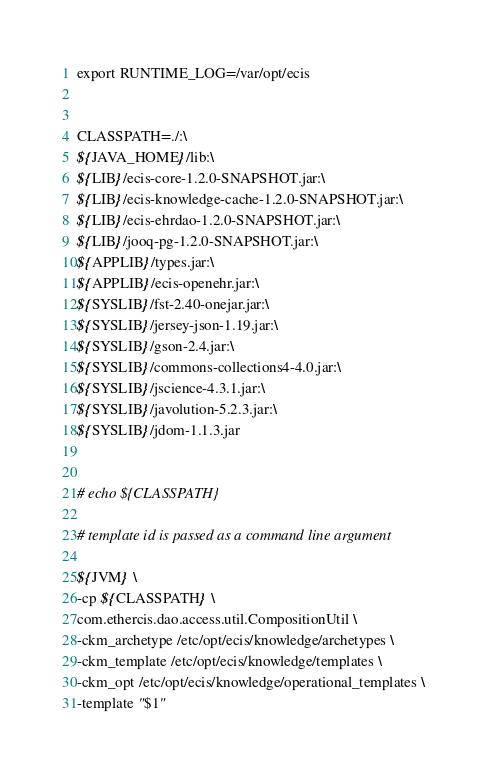Convert code to text. <code><loc_0><loc_0><loc_500><loc_500><_Bash_>export RUNTIME_LOG=/var/opt/ecis


CLASSPATH=./:\
${JAVA_HOME}/lib:\
${LIB}/ecis-core-1.2.0-SNAPSHOT.jar:\
${LIB}/ecis-knowledge-cache-1.2.0-SNAPSHOT.jar:\
${LIB}/ecis-ehrdao-1.2.0-SNAPSHOT.jar:\
${LIB}/jooq-pg-1.2.0-SNAPSHOT.jar:\
${APPLIB}/types.jar:\
${APPLIB}/ecis-openehr.jar:\
${SYSLIB}/fst-2.40-onejar.jar:\
${SYSLIB}/jersey-json-1.19.jar:\
${SYSLIB}/gson-2.4.jar:\
${SYSLIB}/commons-collections4-4.0.jar:\
${SYSLIB}/jscience-4.3.1.jar:\
${SYSLIB}/javolution-5.2.3.jar:\
${SYSLIB}/jdom-1.1.3.jar


# echo ${CLASSPATH}

# template id is passed as a command line argument

${JVM} \
-cp ${CLASSPATH} \
com.ethercis.dao.access.util.CompositionUtil \
-ckm_archetype /etc/opt/ecis/knowledge/archetypes \
-ckm_template /etc/opt/ecis/knowledge/templates \
-ckm_opt /etc/opt/ecis/knowledge/operational_templates \
-template "$1"
</code> 